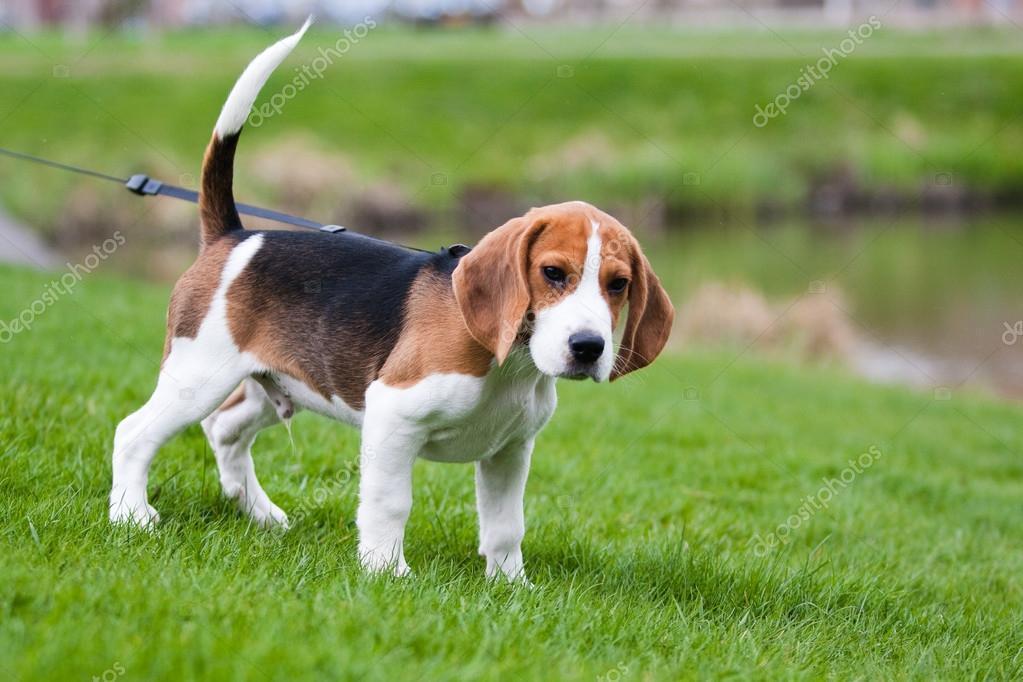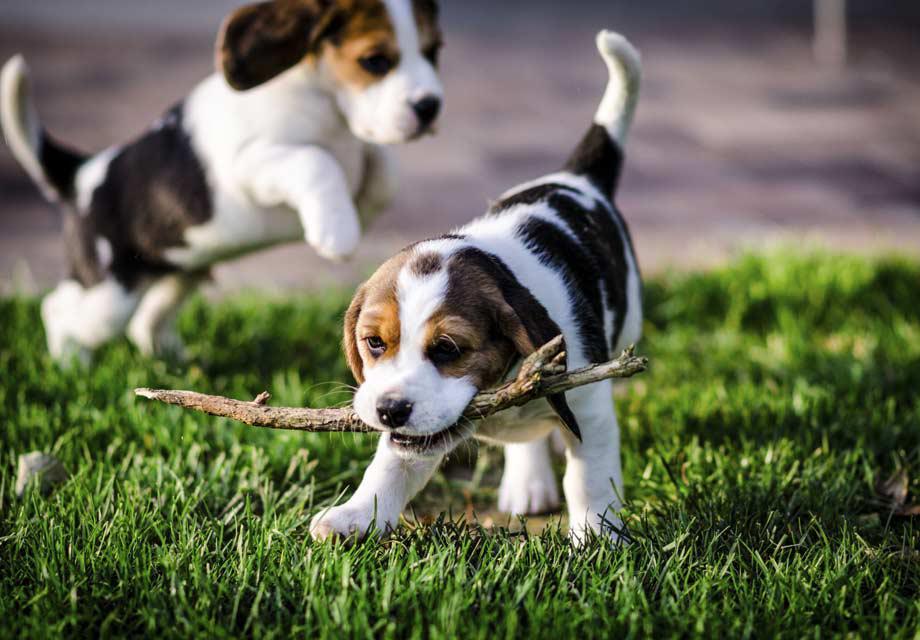The first image is the image on the left, the second image is the image on the right. For the images shown, is this caption "There are two dogs" true? Answer yes or no. No. 